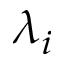Convert formula to latex. <formula><loc_0><loc_0><loc_500><loc_500>\lambda _ { i }</formula> 